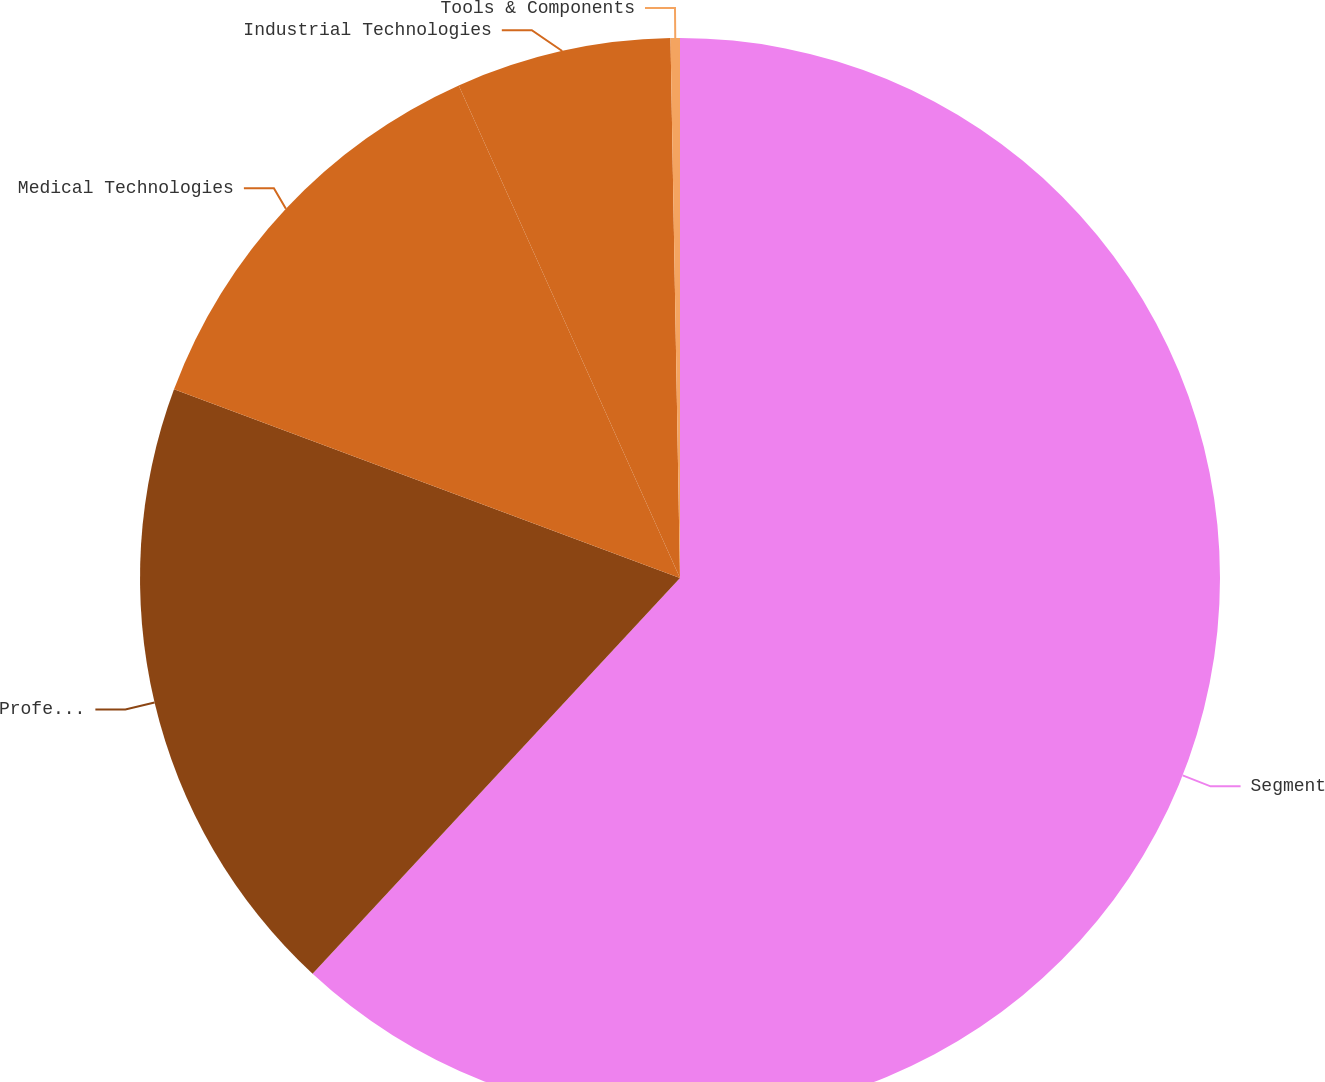Convert chart to OTSL. <chart><loc_0><loc_0><loc_500><loc_500><pie_chart><fcel>Segment<fcel>Professional Instrumentation<fcel>Medical Technologies<fcel>Industrial Technologies<fcel>Tools & Components<nl><fcel>61.91%<fcel>18.77%<fcel>12.6%<fcel>6.44%<fcel>0.28%<nl></chart> 